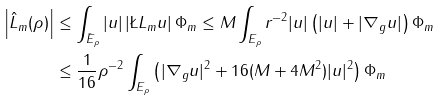<formula> <loc_0><loc_0><loc_500><loc_500>\left | \hat { L } _ { m } ( \rho ) \right | & \leq \int _ { \bar { E } _ { \rho } } | u | \left | \L L _ { m } u \right | \Phi _ { m } \leq M \int _ { { E } _ { \rho } } r ^ { - 2 } | u | \left ( | u | + | \nabla _ { g } u | \right ) \Phi _ { m } \\ & \leq \frac { 1 } { 1 6 } \rho ^ { - 2 } \int _ { { E } _ { \rho } } \left ( | \nabla _ { g } u | ^ { 2 } + 1 6 ( M + 4 M ^ { 2 } ) | u | ^ { 2 } \right ) \Phi _ { m }</formula> 